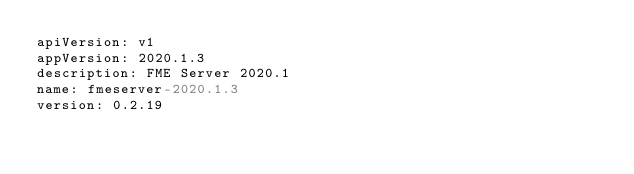<code> <loc_0><loc_0><loc_500><loc_500><_YAML_>apiVersion: v1
appVersion: 2020.1.3 
description: FME Server 2020.1 
name: fmeserver-2020.1.3
version: 0.2.19
</code> 